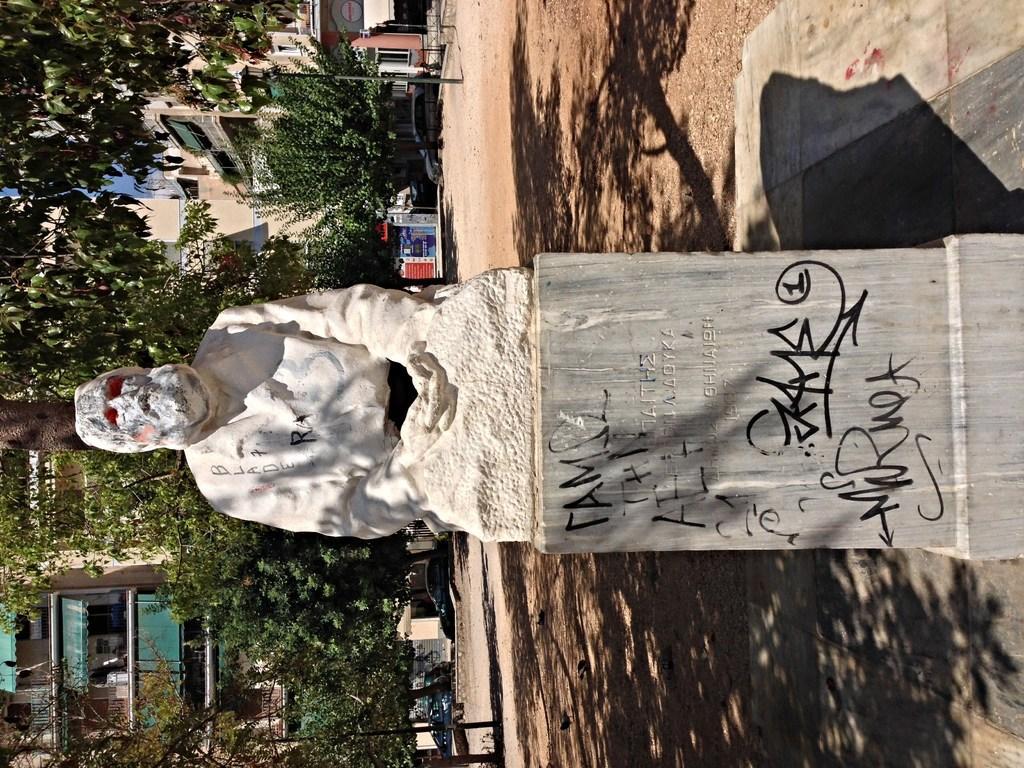Could you give a brief overview of what you see in this image? Something written on this stone. Above this stone there is a statue. Background there are trees, buildings and vehicles. 